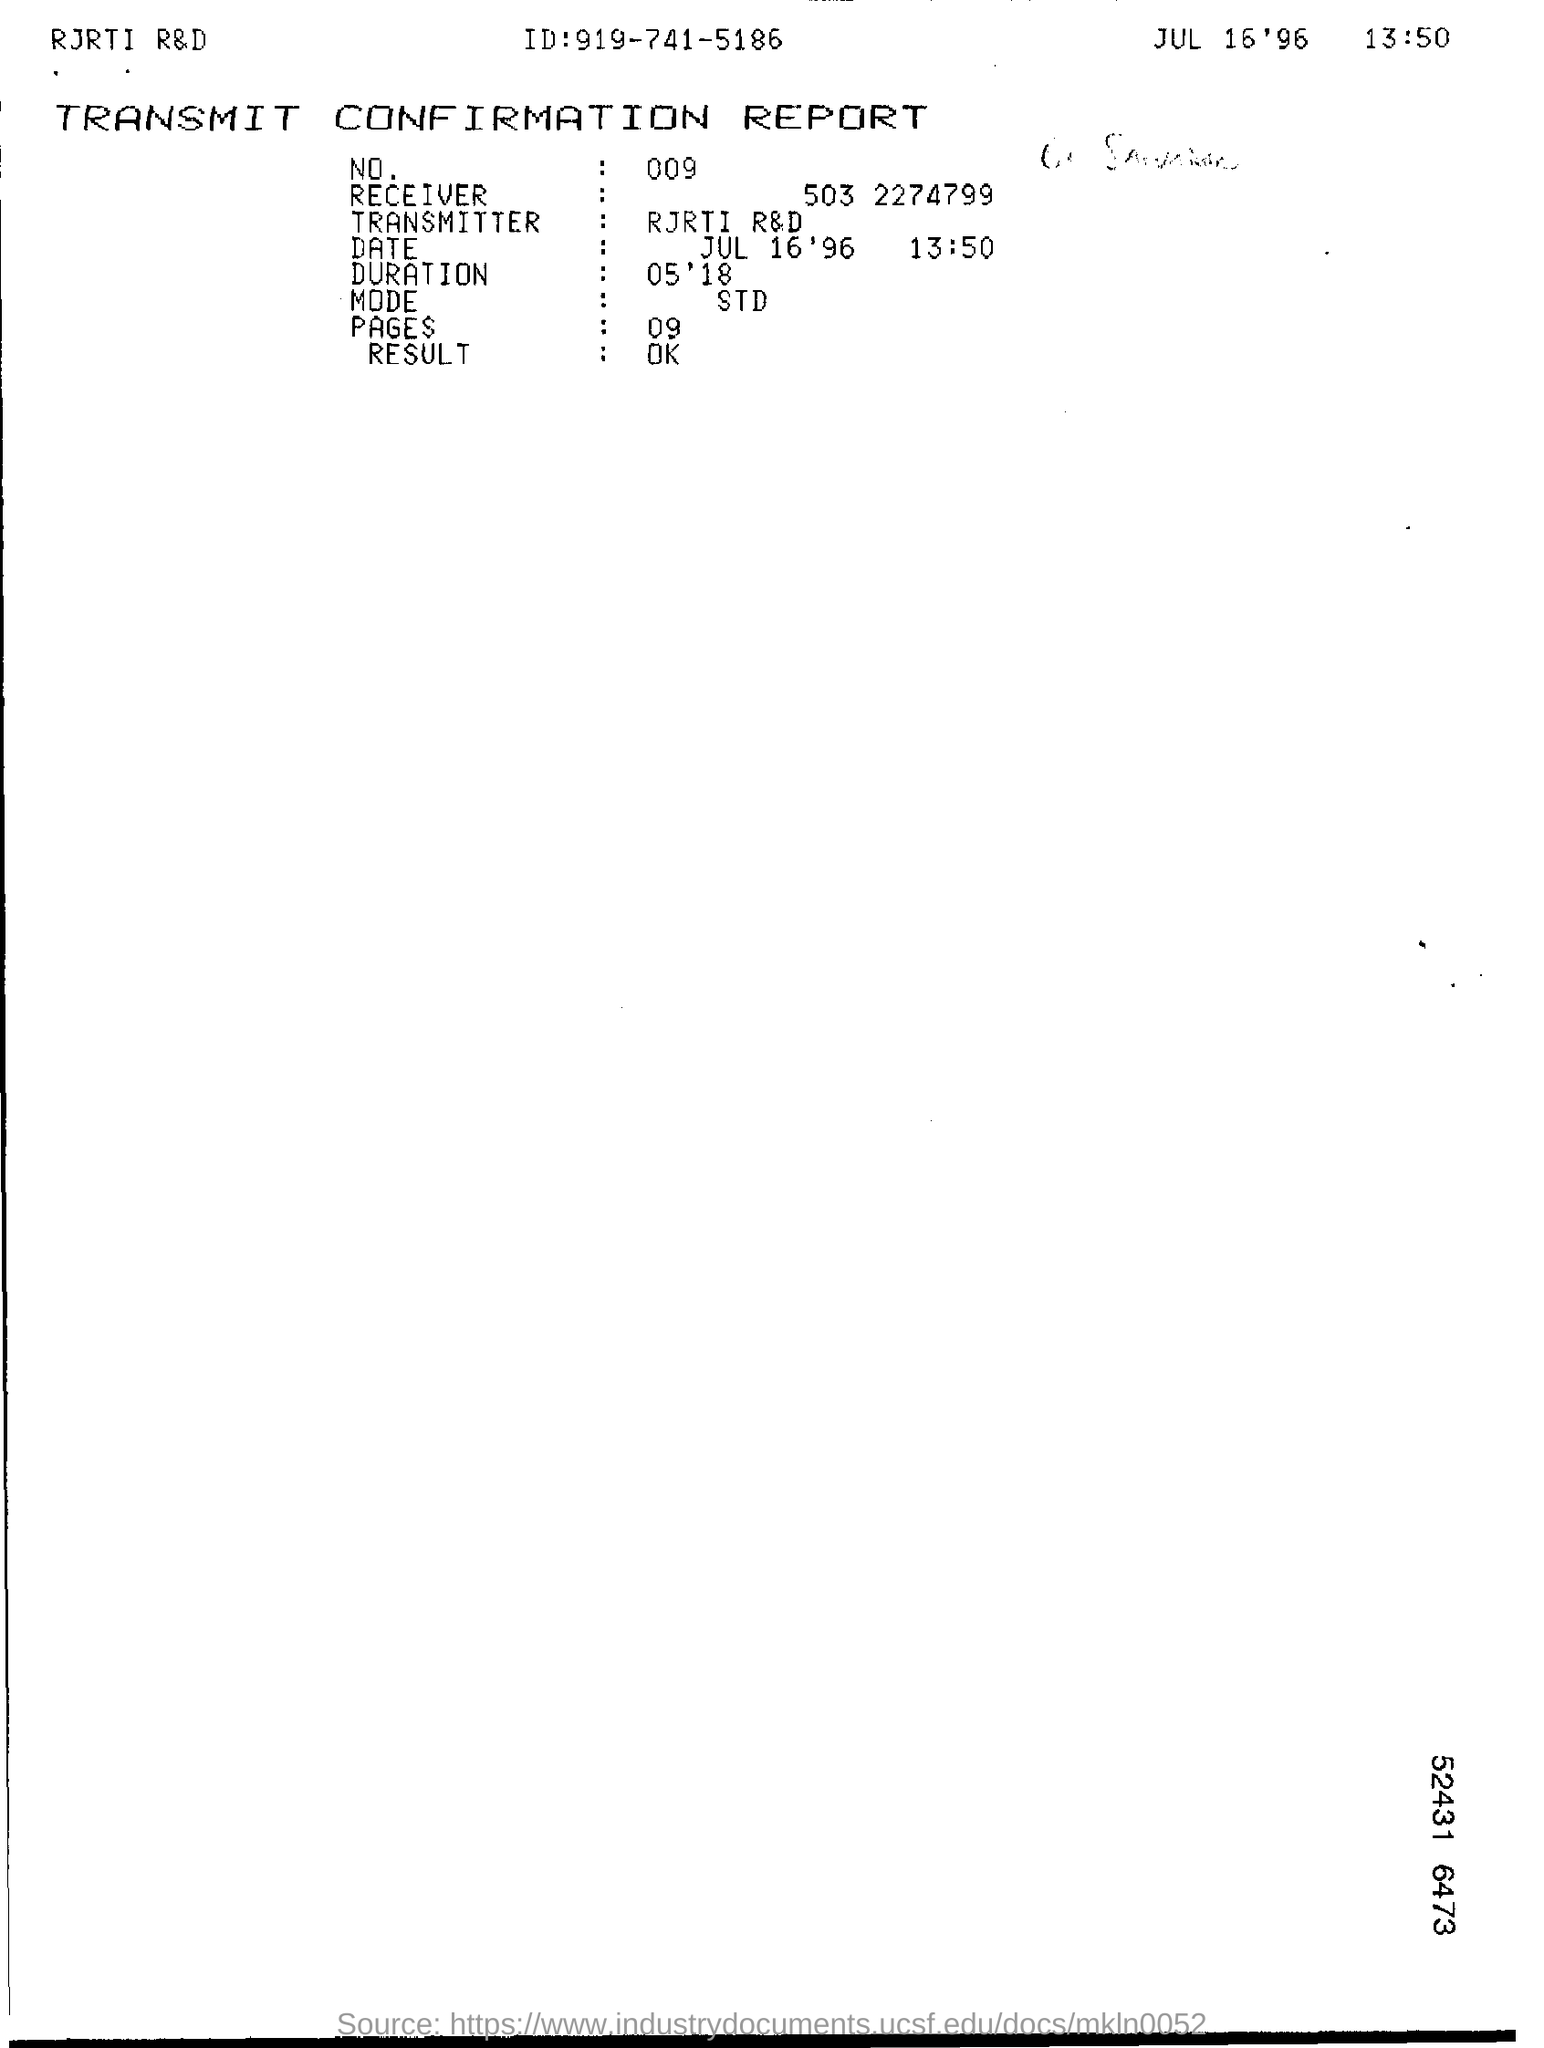What is the ID given in the report?
Keep it short and to the point. 919-741-5186. What is the date mentioned in the transmit confirmation report?
Keep it short and to the point. JUL 16'96   13:50. What is the duration as per the report?
Your response must be concise. 05'18. How many pages are mentioned in the report?
Your answer should be compact. 09. 